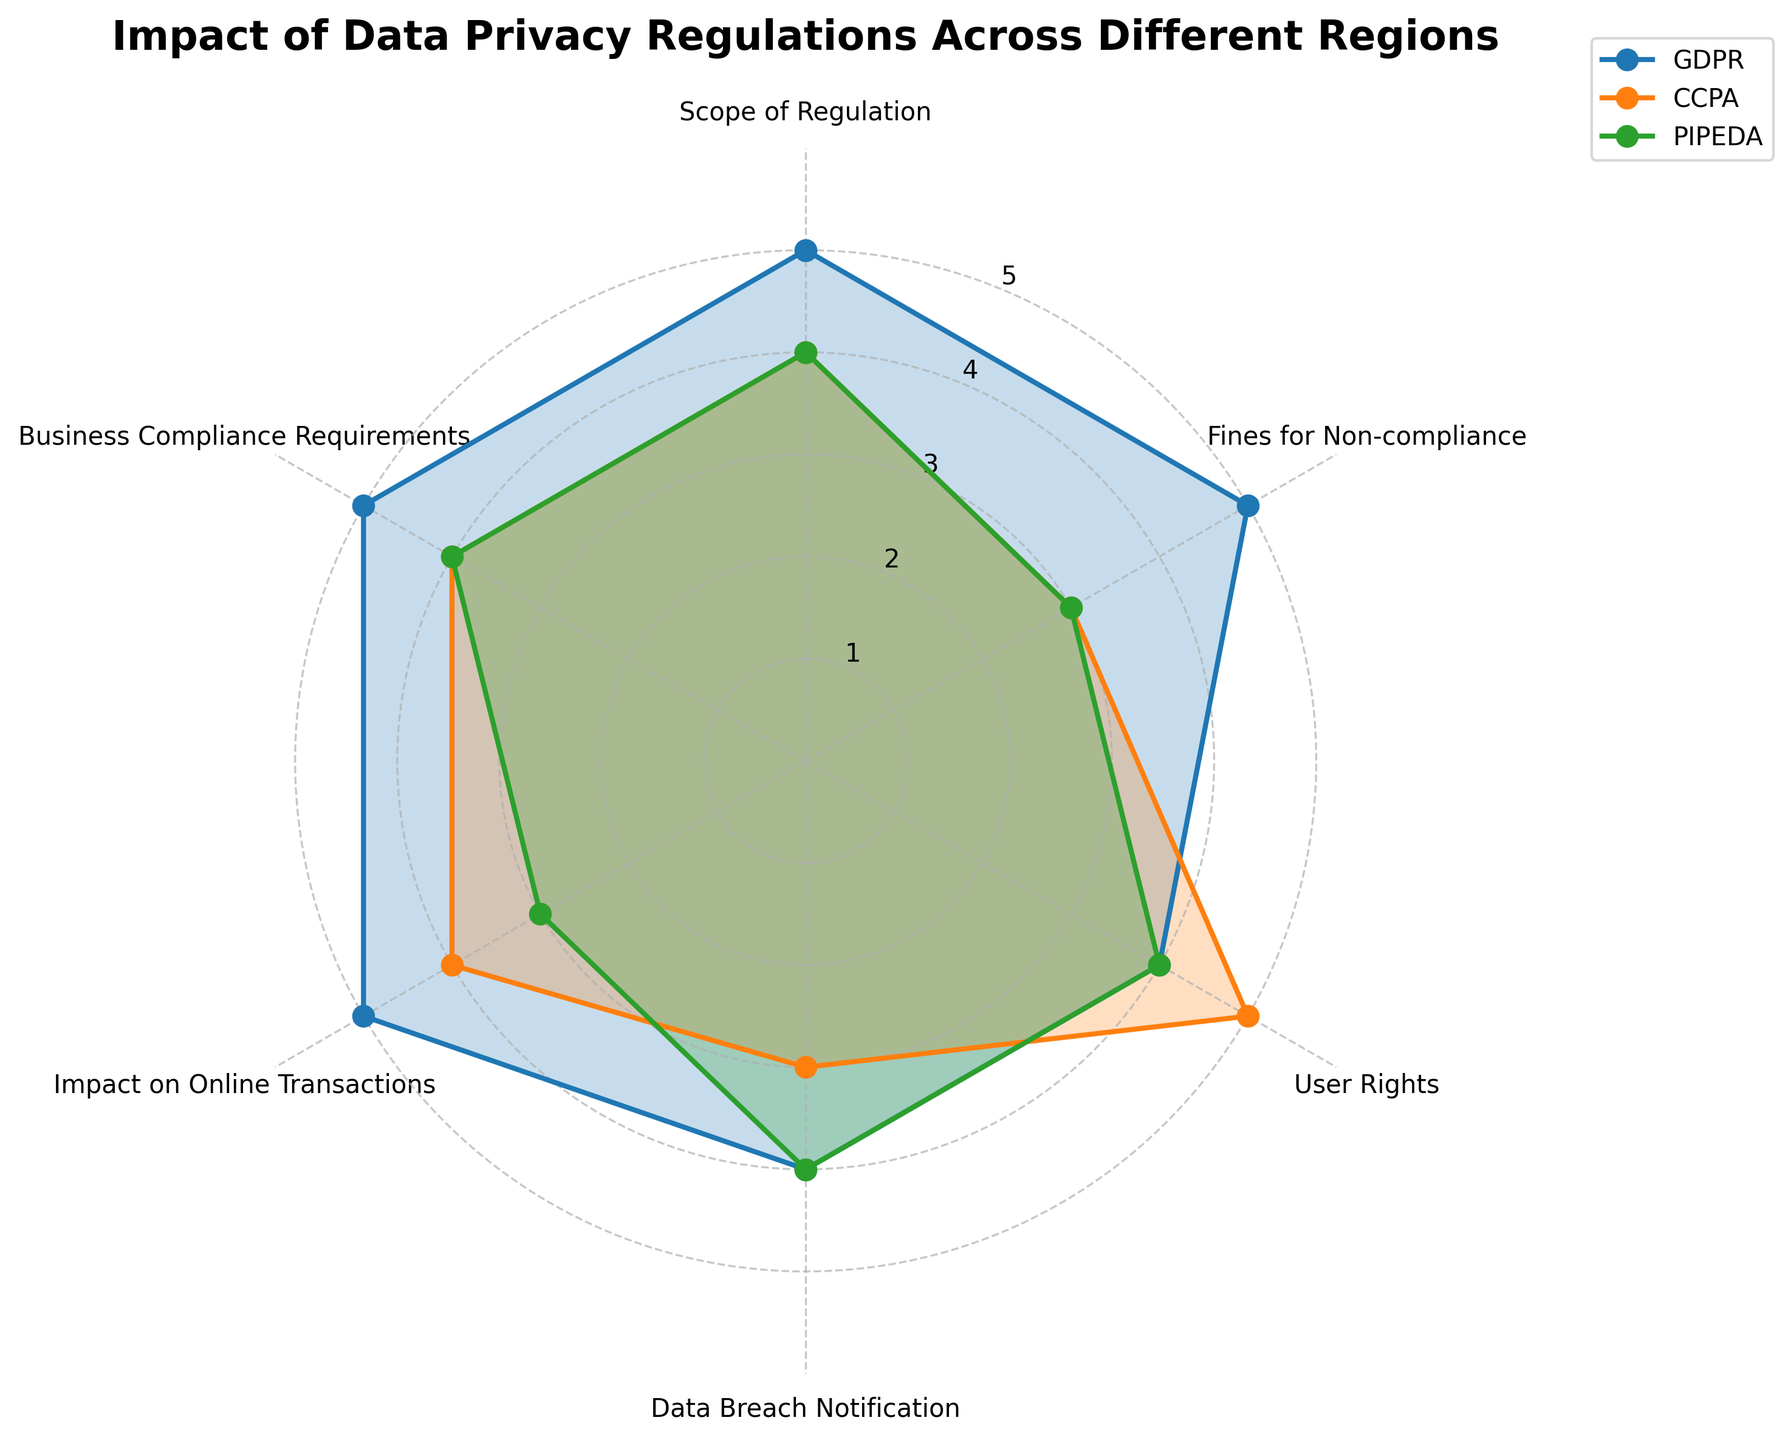What is the title of the radar chart? The title of the radar chart is displayed at the top of the figure in a bold font. It indicates the main topic or subject of the chart.
Answer: Impact of Data Privacy Regulations Across Different Regions Which regulation has the highest score for Fines for Non-compliance? Look at the axis labeled "Fines for Non-compliance" and compare the values assigned to GDPR, CCPA, and PIPEDA.
Answer: GDPR Are the User Rights scores equal for two or more regulations? Refer to the axis marked "User Rights" and check if any two or more values are the same for GDPR, CCPA, and PIPEDA.
Answer: Yes, GDPR and PIPEDA both have a score of 4 What is the average score of CCPA across all categories? Add the scores of CCPA across all the categories: Scope of Regulation (4), Fines for Non-compliance (3), User Rights (5), Data Breach Notification (3), Impact on Online Transactions (4), Business Compliance Requirements (4), sum these values and then divide by the number of categories (6).
Answer: 3.83 Which regulation has the lowest score for Impact on Online Transactions? View the scores for "Impact on Online Transactions" for GDPR, CCPA, and PIPEDA and identify the lowest one.
Answer: PIPEDA How many categories have a score of 5 for GDPR? Identify the radar chart segments corresponding to the categories and count how many times GDPR has a value of 5.
Answer: 4 What is the difference in scores between GDPR and CCPA for Business Compliance Requirements? Find the scores for "Business Compliance Requirements" for both GDPR and CCPA, and then subtract the score of CCPA from that of GDPR.
Answer: 1 Is the coverage area of GDPR larger than that of CCPA? Analyze the radar chart by observing the filled areas for both GDPR and CCPA. Comparing the size or coverage of each region helps determine which is larger.
Answer: Yes Which regulation has the most balanced scores across all categories? Look at the radar chart and compare the range and variation in scores for GDPR, CCPA, and PIPEDA. The most balanced regulation will have the least variation between its highest and lowest scores.
Answer: PIPEDA Which category shows the greatest variation in scores among the regulations? By examining each axis category, identify which one has the largest difference between the highest and lowest scores.
Answer: Fines for Non-compliance 